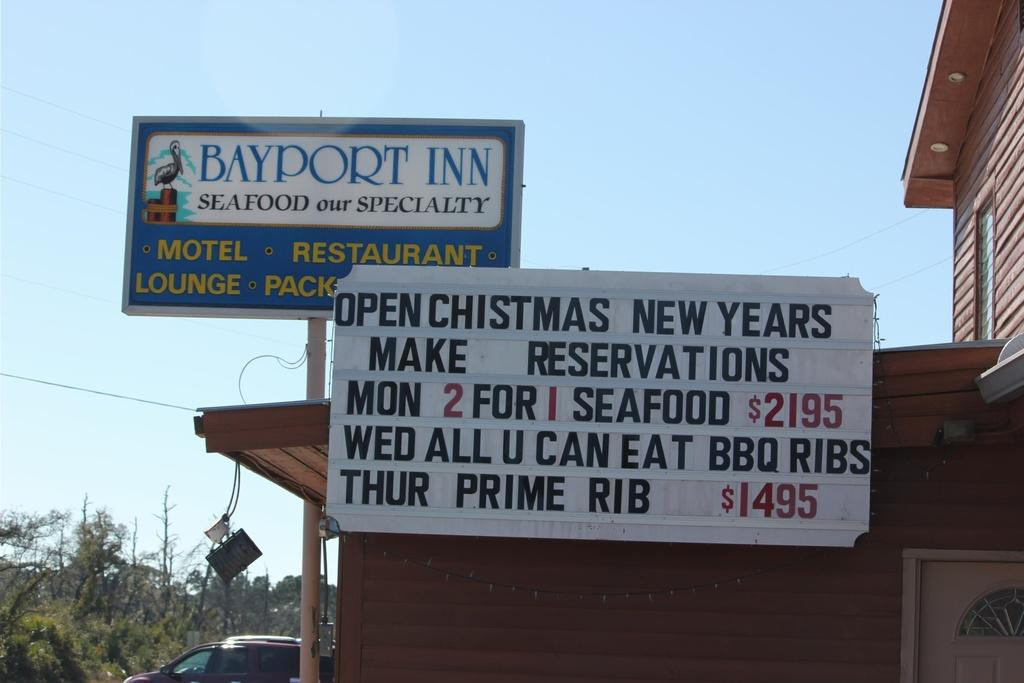<image>
Share a concise interpretation of the image provided. A sign for the Bayport Inn advertising that they are open on Christmas and New Year's. 